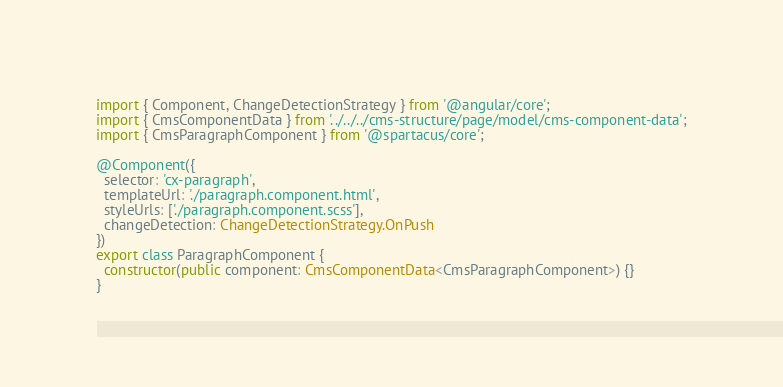<code> <loc_0><loc_0><loc_500><loc_500><_TypeScript_>import { Component, ChangeDetectionStrategy } from '@angular/core';
import { CmsComponentData } from '../../../cms-structure/page/model/cms-component-data';
import { CmsParagraphComponent } from '@spartacus/core';

@Component({
  selector: 'cx-paragraph',
  templateUrl: './paragraph.component.html',
  styleUrls: ['./paragraph.component.scss'],
  changeDetection: ChangeDetectionStrategy.OnPush
})
export class ParagraphComponent {
  constructor(public component: CmsComponentData<CmsParagraphComponent>) {}
}
</code> 